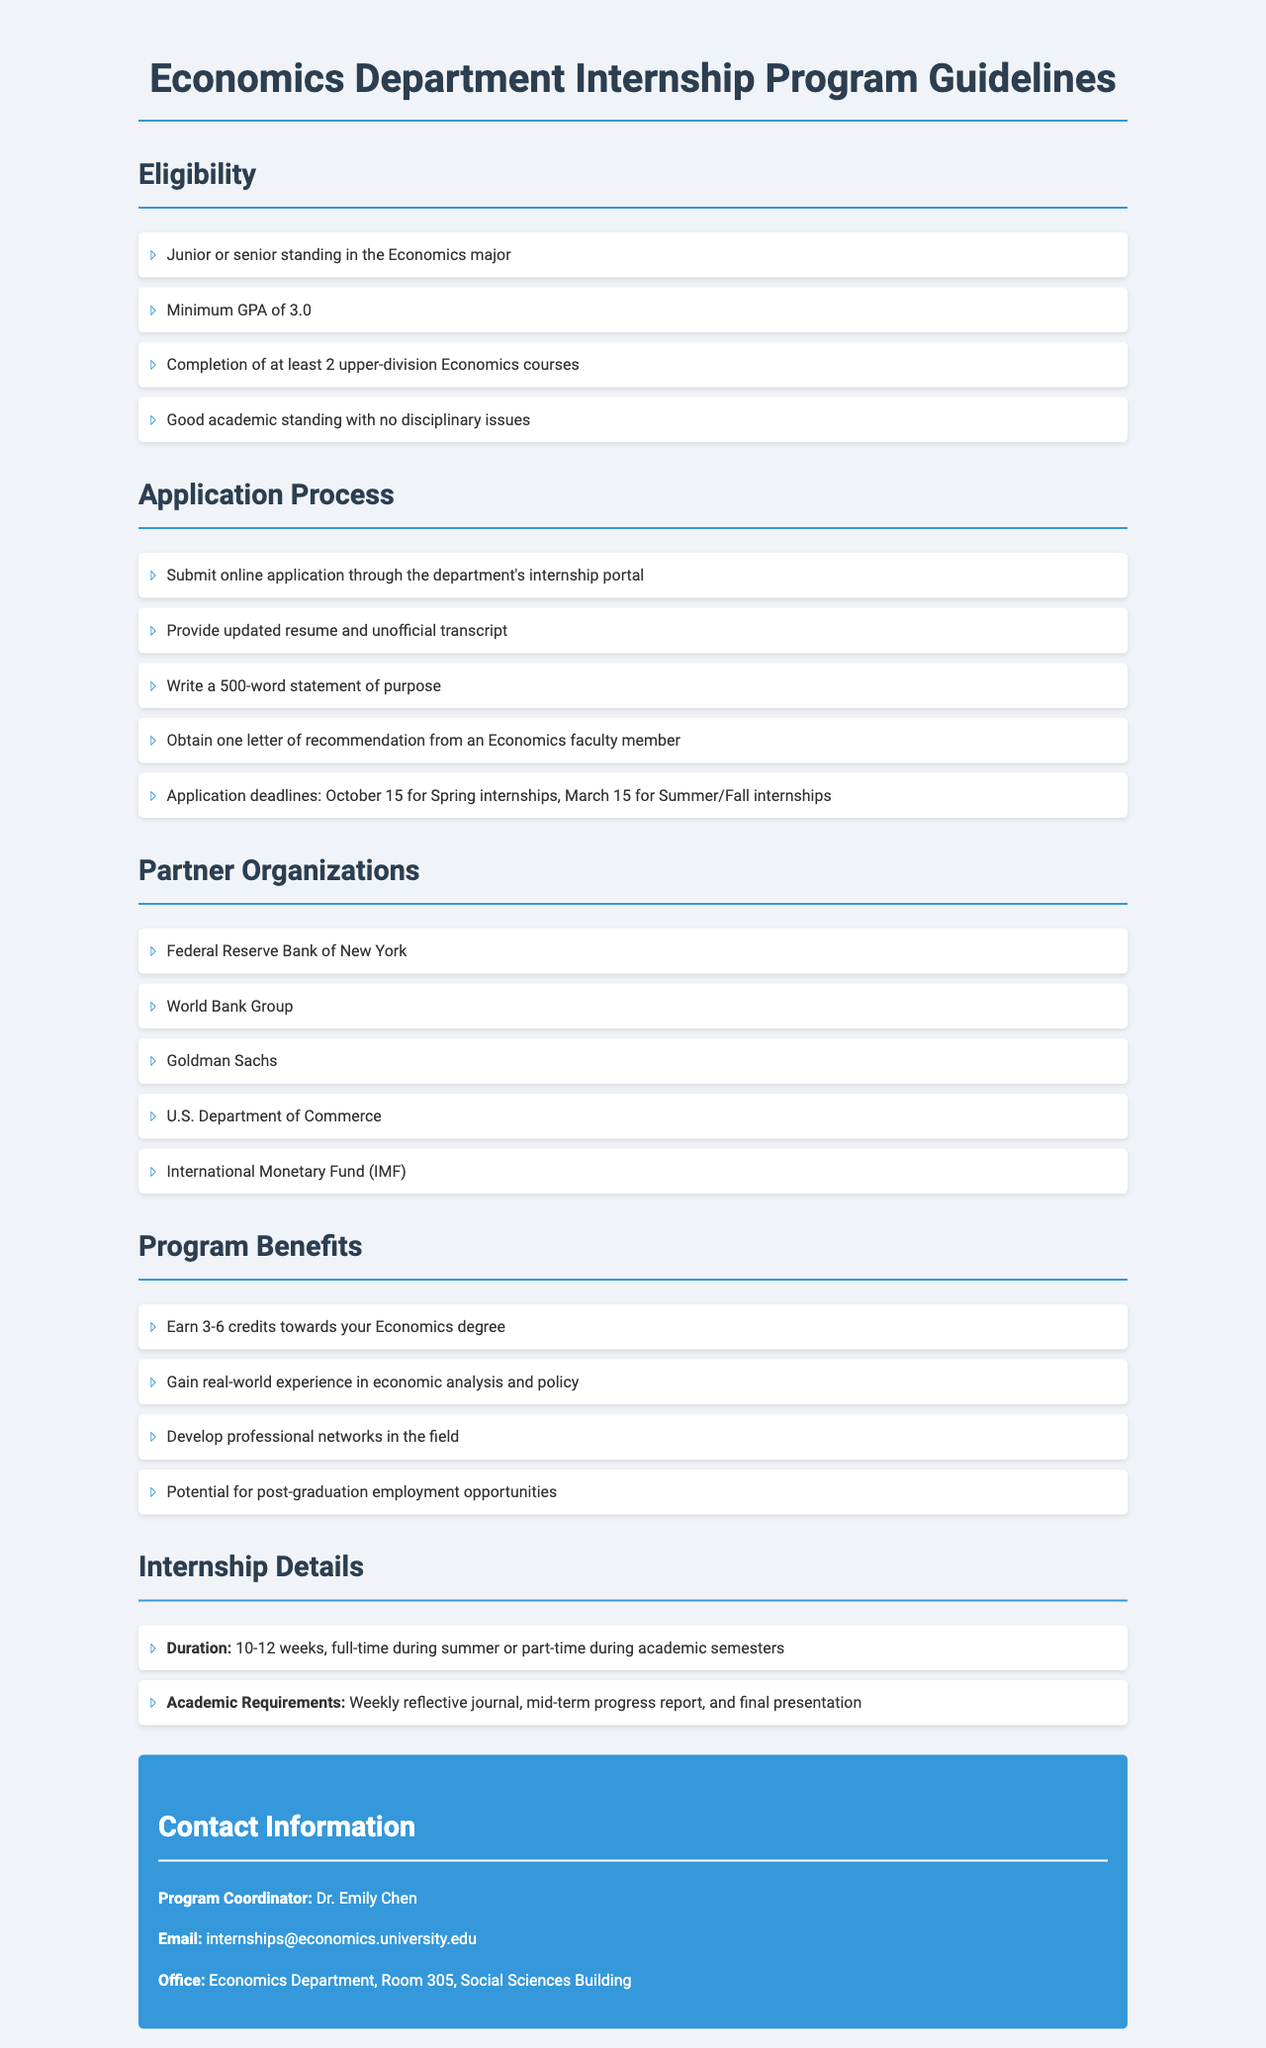What is the minimum GPA required for internship eligibility? The minimum GPA required for internship eligibility, as specified in the guidelines, is 3.0.
Answer: 3.0 Which class standing is required for applicants? The guidelines specify that applicants must have junior or senior standing in the Economics major.
Answer: Junior or senior What is the deadline for Spring internship applications? The document states that the application deadline for Spring internships is October 15.
Answer: October 15 How many university credits can be earned through the internship? According to the guidelines, students can earn 3-6 credits towards their Economics degree through the internship.
Answer: 3-6 credits Which organization is one of the partner organizations listed? The guidelines provide a list of partner organizations, one of which is the Federal Reserve Bank of New York.
Answer: Federal Reserve Bank of New York What must be included in the statement of purpose? The guidelines detail that the statement of purpose should be 500 words long.
Answer: 500-word What type of report is required during the internship? The document mentions that a mid-term progress report is required during the internship.
Answer: Mid-term progress report How long is the duration of most internships? The internship duration is specified to be 10-12 weeks.
Answer: 10-12 weeks Who is the Program Coordinator? The guidelines indicate that Dr. Emily Chen is the Program Coordinator for the internship program.
Answer: Dr. Emily Chen 